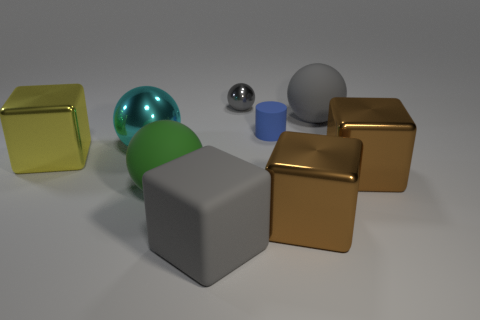Subtract 1 blocks. How many blocks are left? 3 Subtract all cylinders. How many objects are left? 8 Add 4 brown metal things. How many brown metal things are left? 6 Add 2 brown objects. How many brown objects exist? 4 Subtract 1 yellow blocks. How many objects are left? 8 Subtract all tiny blue rubber objects. Subtract all large rubber cubes. How many objects are left? 7 